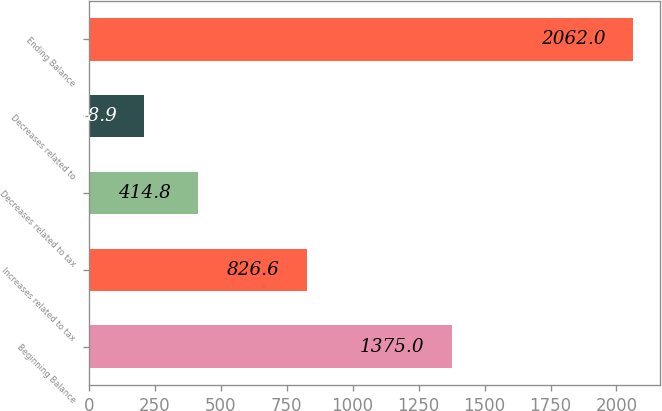Convert chart to OTSL. <chart><loc_0><loc_0><loc_500><loc_500><bar_chart><fcel>Beginning Balance<fcel>Increases related to tax<fcel>Decreases related to tax<fcel>Decreases related to<fcel>Ending Balance<nl><fcel>1375<fcel>826.6<fcel>414.8<fcel>208.9<fcel>2062<nl></chart> 